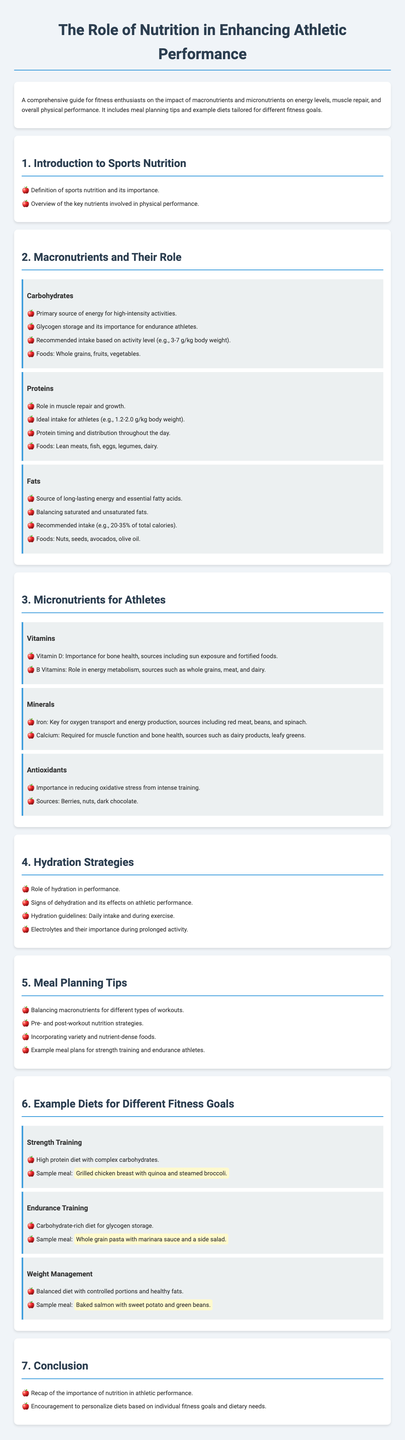What is the primary source of energy for high-intensity activities? Carbohydrates are identified as the primary source of energy for high-intensity activities in the syllabus.
Answer: Carbohydrates What is the recommended protein intake for athletes per kilogram of body weight? The syllabus states that the ideal protein intake for athletes is between 1.2 to 2.0 grams per kilogram of body weight.
Answer: 1.2-2.0 g/kg Which vitamin is important for bone health? Vitamin D is highlighted in the document for its importance in maintaining bone health.
Answer: Vitamin D What are signs of dehydration? The syllabus includes a section on hydration strategies that mentions signs of dehydration as important information.
Answer: Signs of dehydration What is a sample meal for strength training? The document provides a specific example of a meal suitable for strength training, which includes grilled chicken breast, quinoa, and steamed broccoli.
Answer: Grilled chicken breast with quinoa and steamed broccoli How many grams of carbohydrates are recommended based on activity level? The syllabus suggests a carbohydrate intake based on activity level, specifically stating 3-7 grams per kilogram of body weight.
Answer: 3-7 g/kg What role do antioxidants play for athletes? Antioxidants are discussed in the document as important in reducing oxidative stress from intense training.
Answer: Reducing oxidative stress What is an essential fatty acid source mentioned in the document? The syllabus identifies sources of essential fatty acids, one example being nuts.
Answer: Nuts 